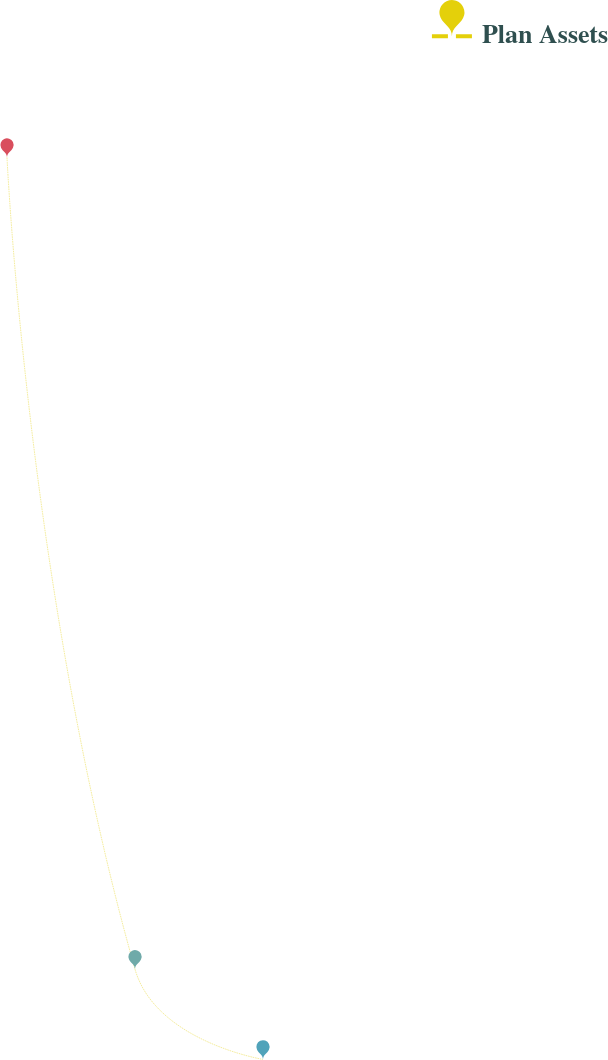Convert chart to OTSL. <chart><loc_0><loc_0><loc_500><loc_500><line_chart><ecel><fcel>Plan Assets<nl><fcel>26.76<fcel>2376.42<nl><fcel>218.25<fcel>262.47<nl><fcel>409.74<fcel>27.59<nl><fcel>1941.65<fcel>497.35<nl></chart> 